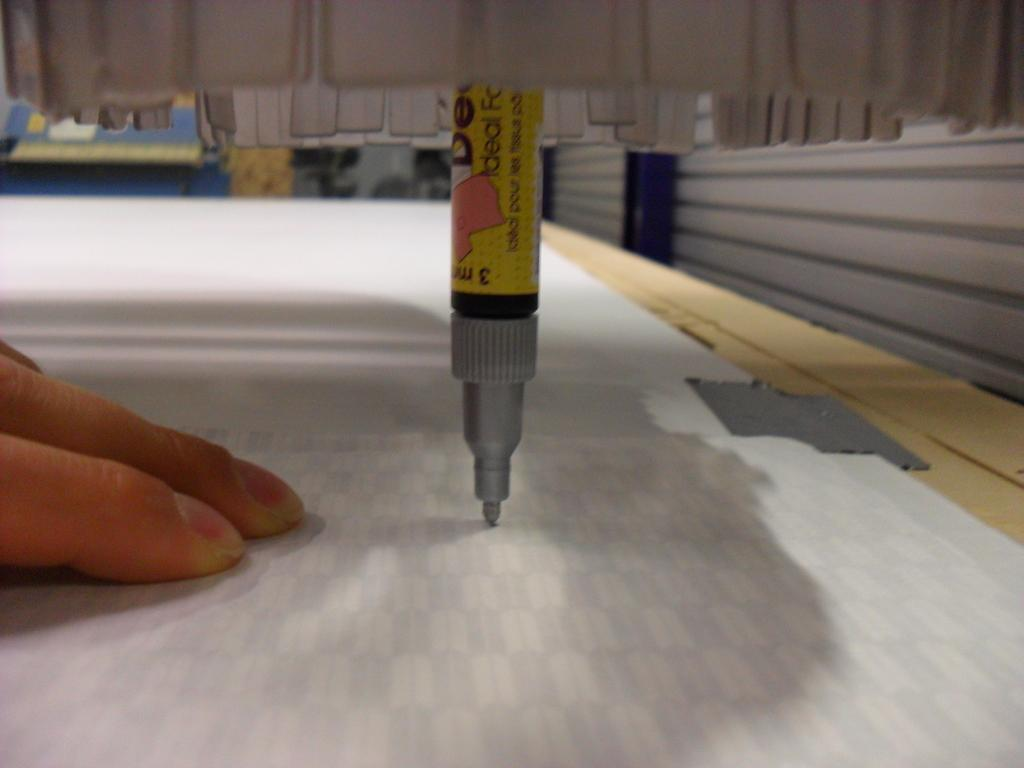Provide a one-sentence caption for the provided image. a marker facing directly downward on paper with a label that says 'ideal' on it. 